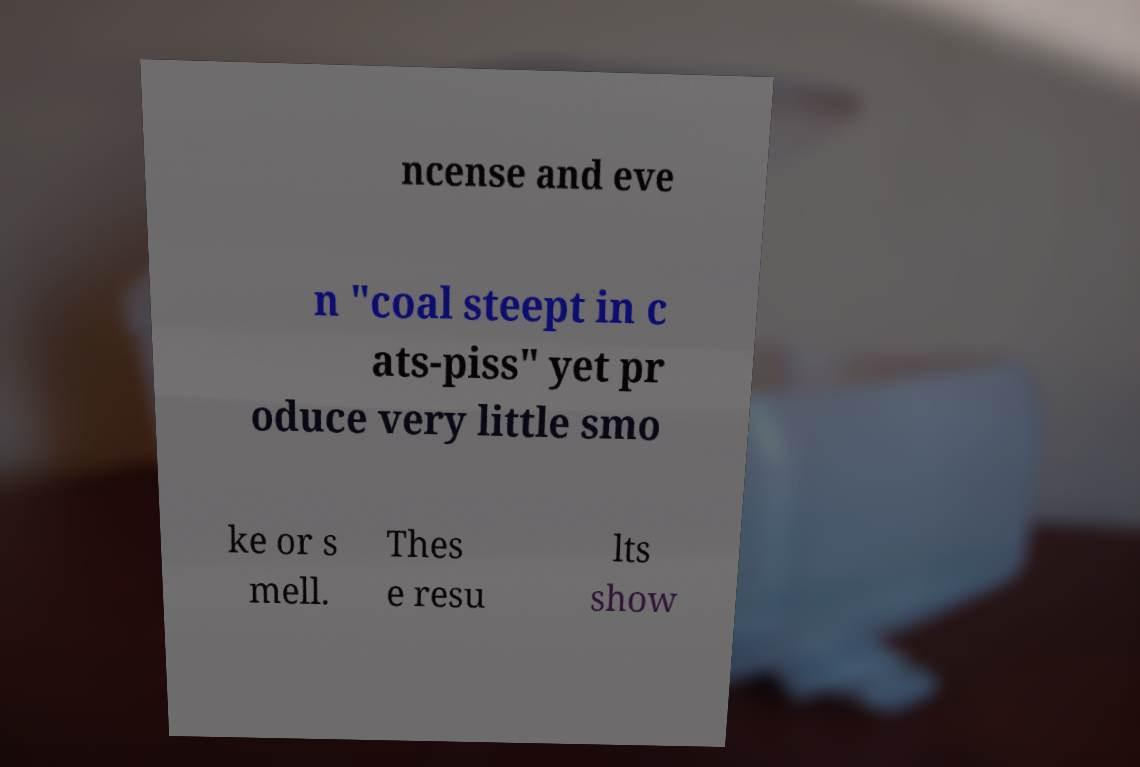I need the written content from this picture converted into text. Can you do that? ncense and eve n "coal steept in c ats-piss" yet pr oduce very little smo ke or s mell. Thes e resu lts show 